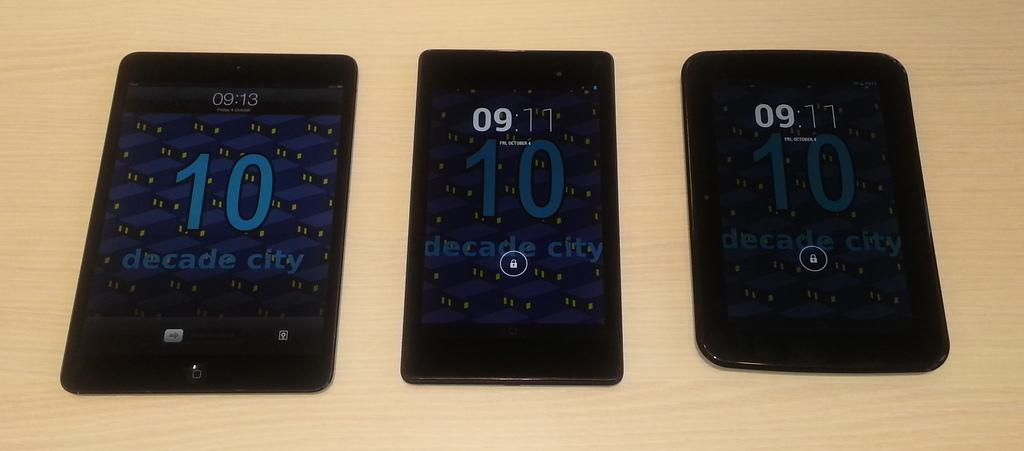<image>
Write a terse but informative summary of the picture. Three different smart phones which read decade city near the bottom of the screen. 